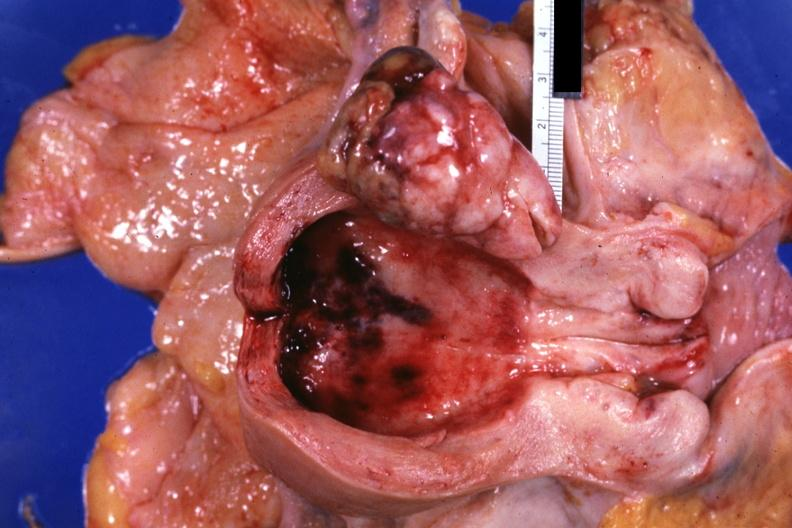s normal immature infant present?
Answer the question using a single word or phrase. No 